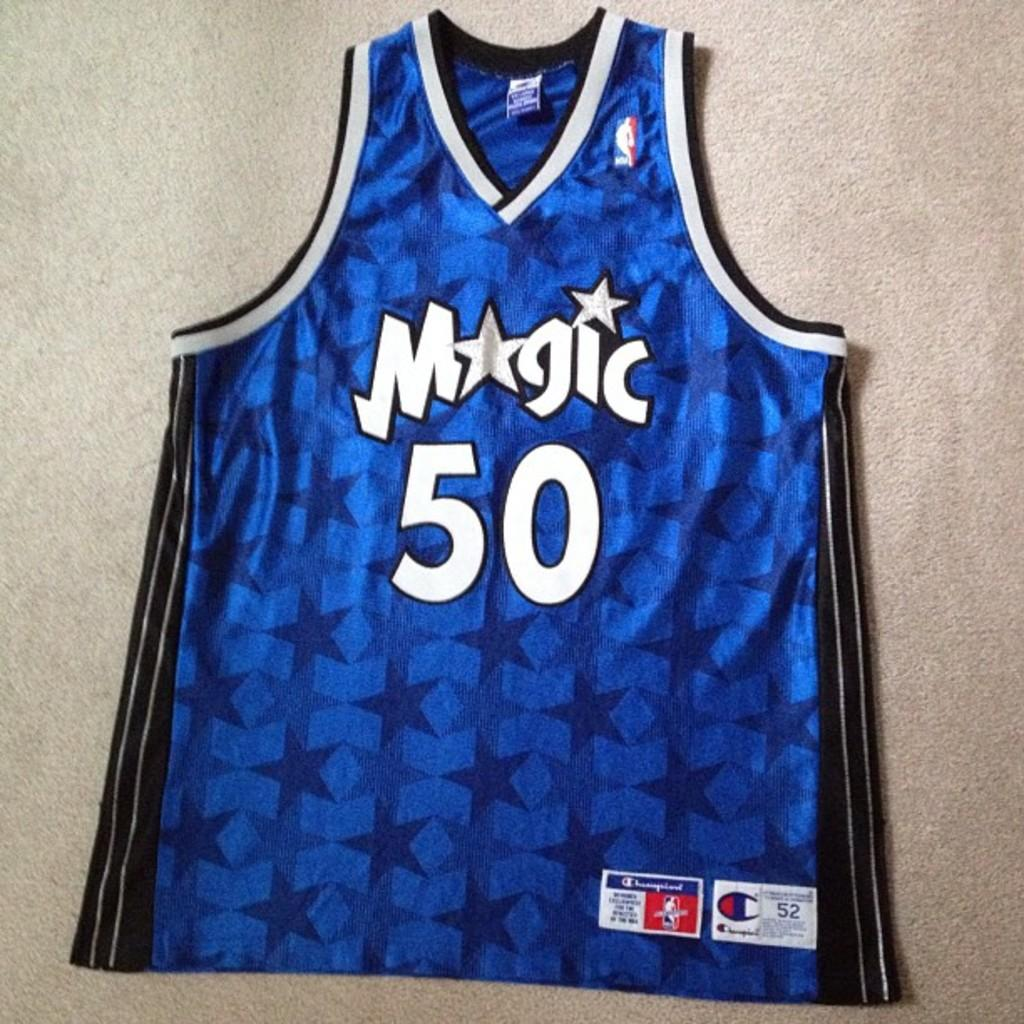<image>
Provide a brief description of the given image. A blue basketball jersey says Magic 50 and is laying on white carpet. 